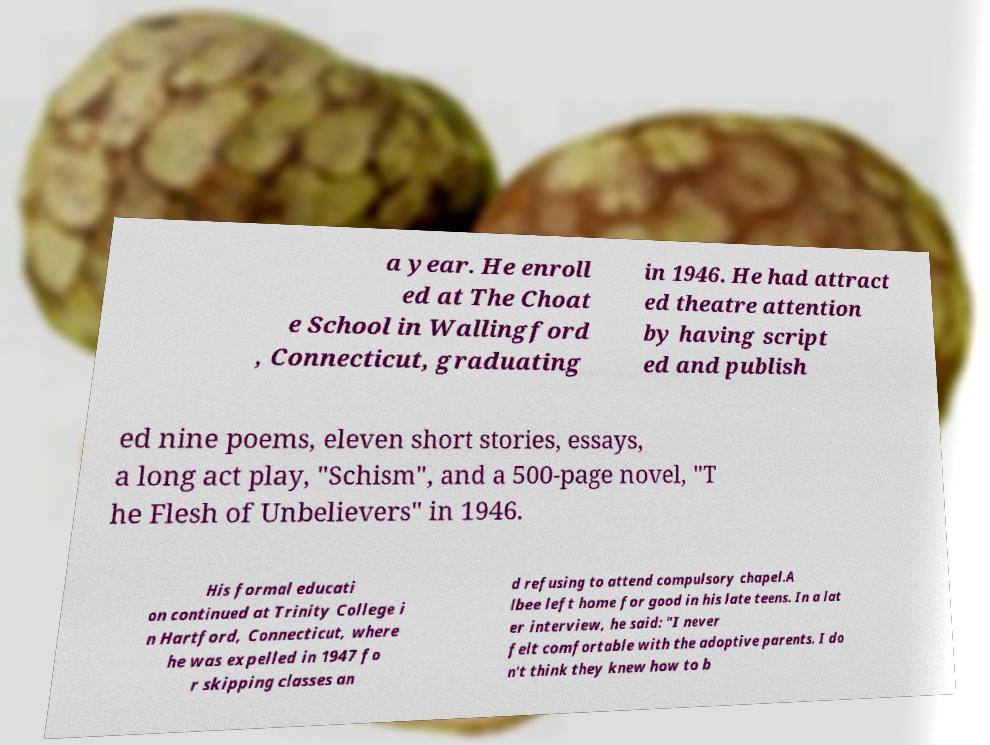Please read and relay the text visible in this image. What does it say? a year. He enroll ed at The Choat e School in Wallingford , Connecticut, graduating in 1946. He had attract ed theatre attention by having script ed and publish ed nine poems, eleven short stories, essays, a long act play, "Schism", and a 500-page novel, "T he Flesh of Unbelievers" in 1946. His formal educati on continued at Trinity College i n Hartford, Connecticut, where he was expelled in 1947 fo r skipping classes an d refusing to attend compulsory chapel.A lbee left home for good in his late teens. In a lat er interview, he said: "I never felt comfortable with the adoptive parents. I do n't think they knew how to b 